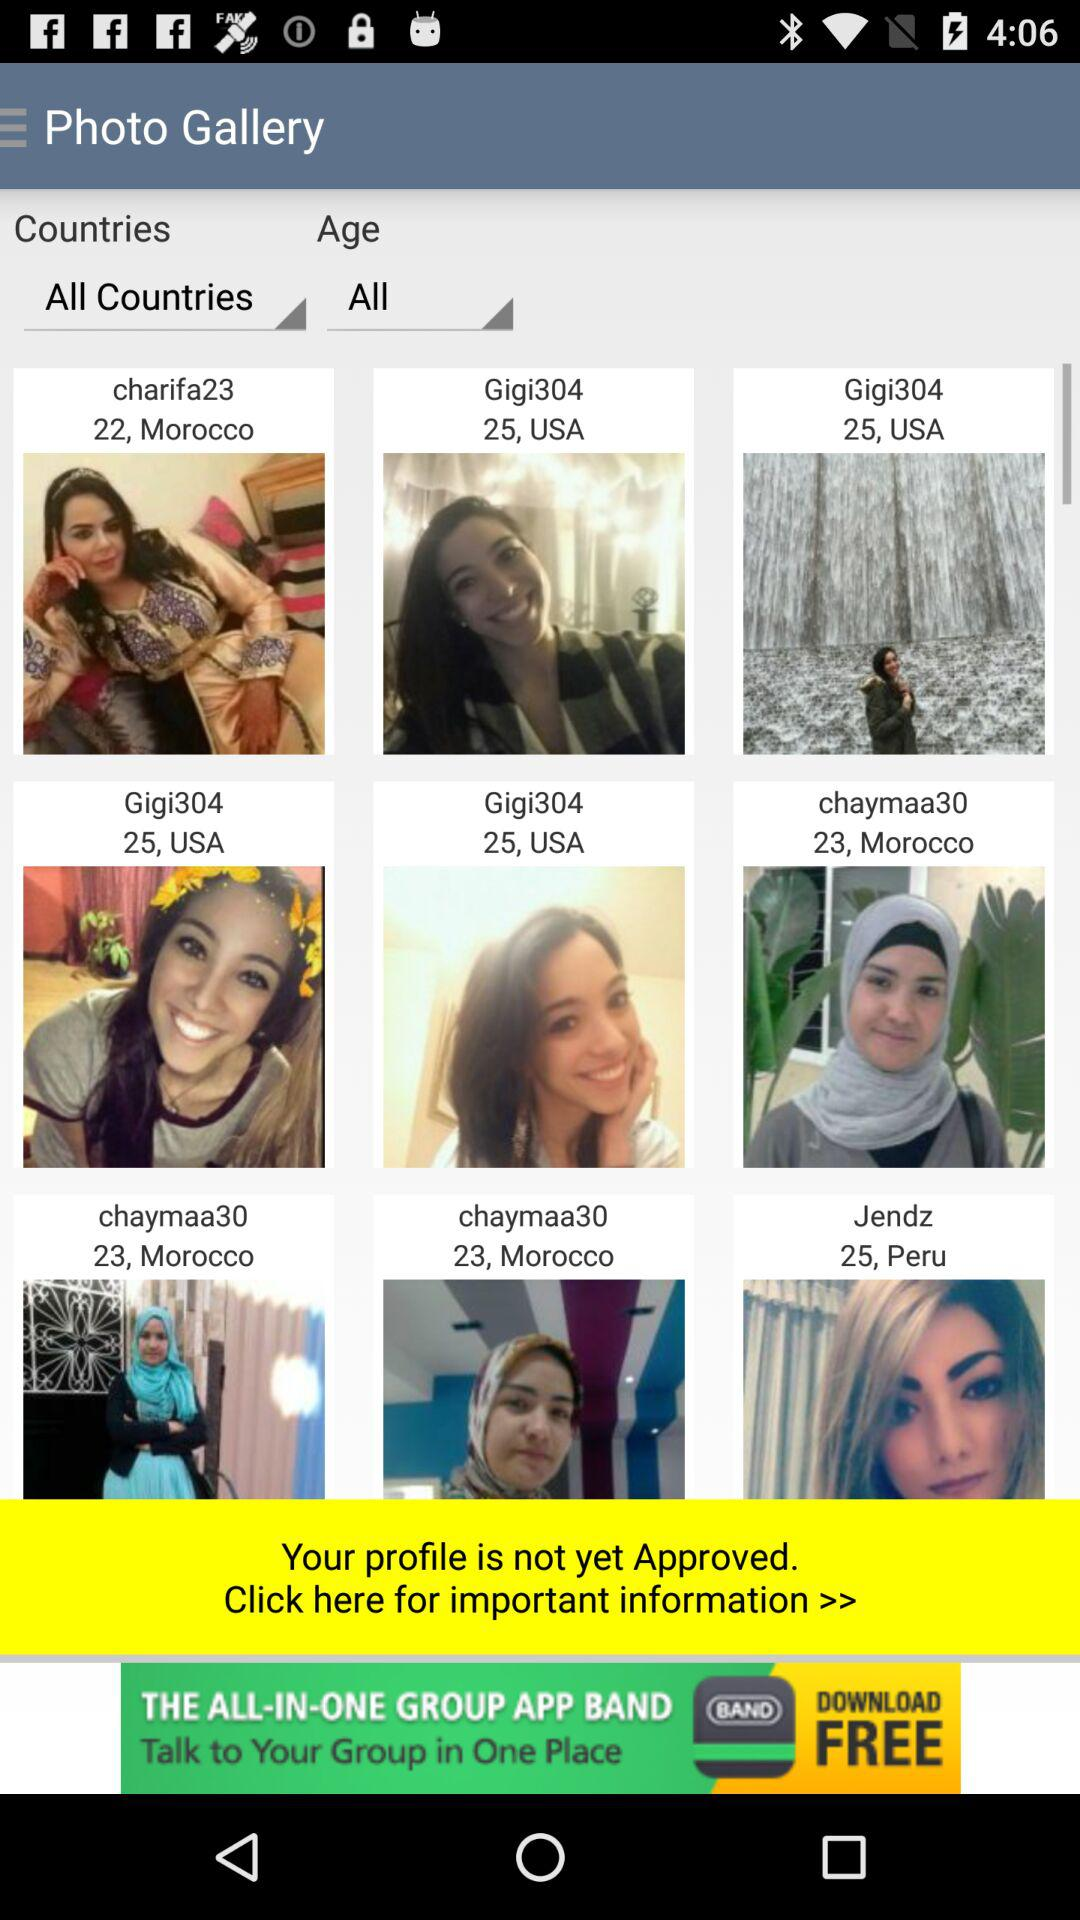What is the age of "Jendz"? The age of "Jendz" is 25 years. 